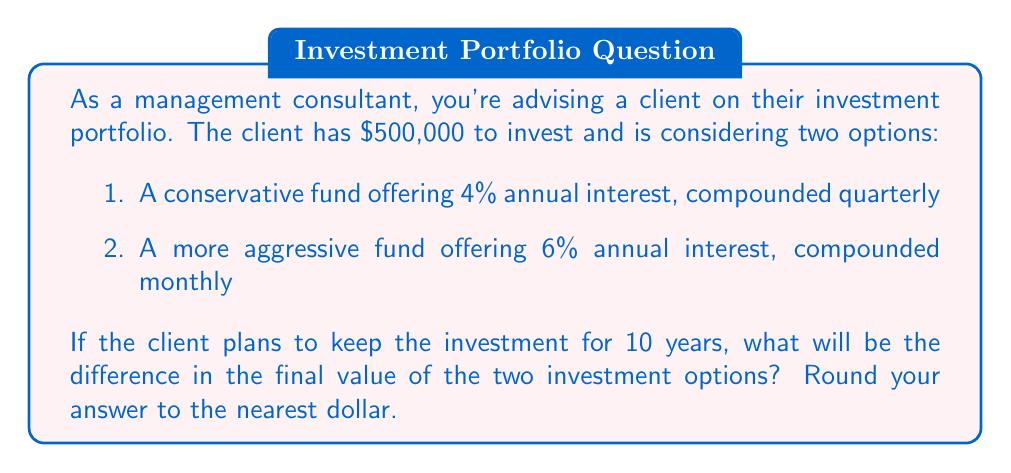Teach me how to tackle this problem. To solve this problem, we'll use the compound interest formula:

$$A = P(1 + \frac{r}{n})^{nt}$$

Where:
$A$ = final amount
$P$ = principal (initial investment)
$r$ = annual interest rate (in decimal form)
$n$ = number of times interest is compounded per year
$t$ = number of years

For Option 1 (Conservative Fund):
$P = 500,000$
$r = 0.04$ (4% annual interest)
$n = 4$ (compounded quarterly)
$t = 10$ years

$$A_1 = 500,000(1 + \frac{0.04}{4})^{4(10)}$$
$$A_1 = 500,000(1.01)^{40}$$
$$A_1 = 500,000(1.4889)$$
$$A_1 = 744,450.97$$

For Option 2 (Aggressive Fund):
$P = 500,000$
$r = 0.06$ (6% annual interest)
$n = 12$ (compounded monthly)
$t = 10$ years

$$A_2 = 500,000(1 + \frac{0.06}{12})^{12(10)}$$
$$A_2 = 500,000(1.005)^{120}$$
$$A_2 = 500,000(1.8194)$$
$$A_2 = 909,700.46$$

The difference between the two options is:
$$909,700.46 - 744,450.97 = 165,249.49$$

Rounded to the nearest dollar, the difference is $165,249.
Answer: $165,249 